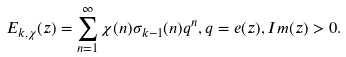<formula> <loc_0><loc_0><loc_500><loc_500>E _ { k , \chi } ( z ) = \sum ^ { \infty } _ { n = 1 } \chi ( n ) \sigma _ { k - 1 } ( n ) q ^ { n } , q = e ( z ) , I m ( z ) > 0 .</formula> 